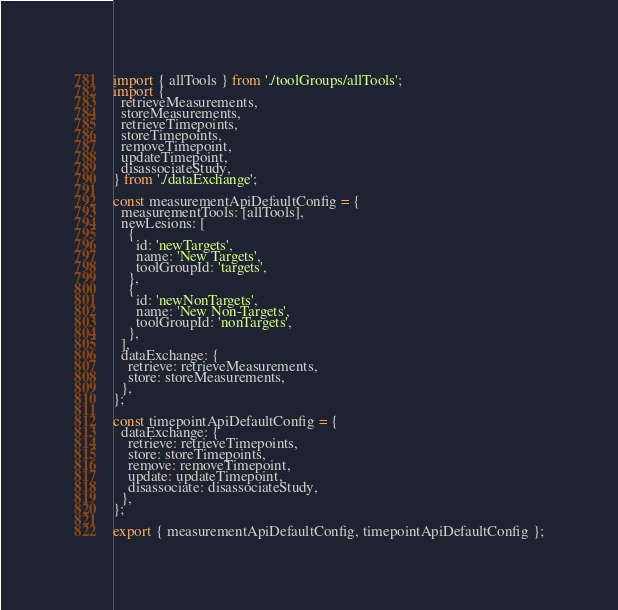<code> <loc_0><loc_0><loc_500><loc_500><_JavaScript_>import { allTools } from './toolGroups/allTools';
import {
  retrieveMeasurements,
  storeMeasurements,
  retrieveTimepoints,
  storeTimepoints,
  removeTimepoint,
  updateTimepoint,
  disassociateStudy,
} from './dataExchange';

const measurementApiDefaultConfig = {
  measurementTools: [allTools],
  newLesions: [
    {
      id: 'newTargets',
      name: 'New Targets',
      toolGroupId: 'targets',
    },
    {
      id: 'newNonTargets',
      name: 'New Non-Targets',
      toolGroupId: 'nonTargets',
    },
  ],
  dataExchange: {
    retrieve: retrieveMeasurements,
    store: storeMeasurements,
  },
};

const timepointApiDefaultConfig = {
  dataExchange: {
    retrieve: retrieveTimepoints,
    store: storeTimepoints,
    remove: removeTimepoint,
    update: updateTimepoint,
    disassociate: disassociateStudy,
  },
};

export { measurementApiDefaultConfig, timepointApiDefaultConfig };
</code> 